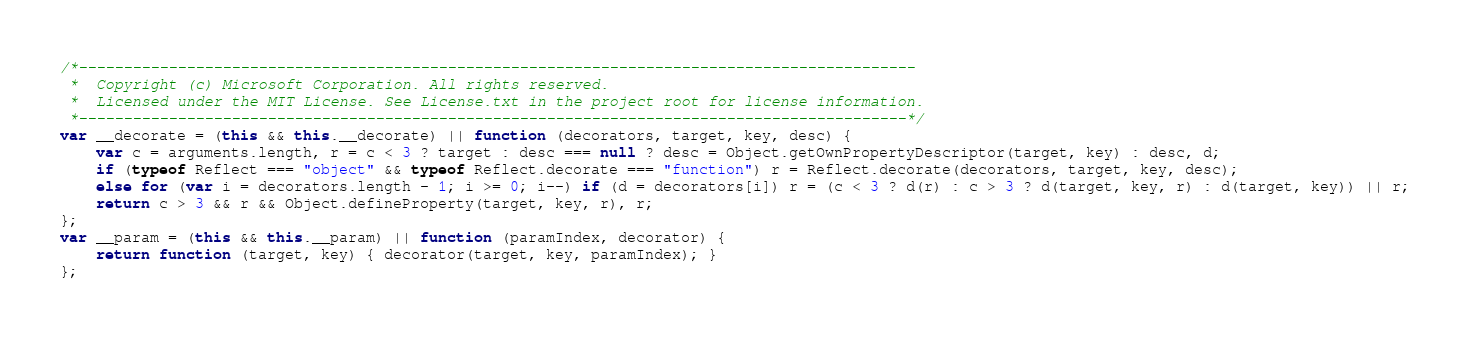<code> <loc_0><loc_0><loc_500><loc_500><_JavaScript_>/*---------------------------------------------------------------------------------------------
 *  Copyright (c) Microsoft Corporation. All rights reserved.
 *  Licensed under the MIT License. See License.txt in the project root for license information.
 *--------------------------------------------------------------------------------------------*/
var __decorate = (this && this.__decorate) || function (decorators, target, key, desc) {
    var c = arguments.length, r = c < 3 ? target : desc === null ? desc = Object.getOwnPropertyDescriptor(target, key) : desc, d;
    if (typeof Reflect === "object" && typeof Reflect.decorate === "function") r = Reflect.decorate(decorators, target, key, desc);
    else for (var i = decorators.length - 1; i >= 0; i--) if (d = decorators[i]) r = (c < 3 ? d(r) : c > 3 ? d(target, key, r) : d(target, key)) || r;
    return c > 3 && r && Object.defineProperty(target, key, r), r;
};
var __param = (this && this.__param) || function (paramIndex, decorator) {
    return function (target, key) { decorator(target, key, paramIndex); }
};</code> 